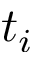<formula> <loc_0><loc_0><loc_500><loc_500>t _ { i }</formula> 